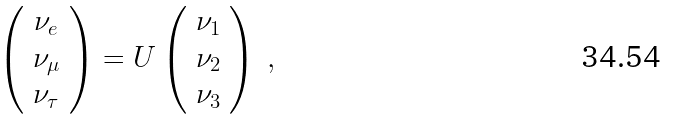<formula> <loc_0><loc_0><loc_500><loc_500>\left ( \begin{array} { c } \nu _ { e } \\ \nu _ { \mu } \\ \nu _ { \tau } \end{array} \right ) = U \left ( \begin{array} { c } \nu _ { 1 } \\ \nu _ { 2 } \\ \nu _ { 3 } \end{array} \right ) \ ,</formula> 